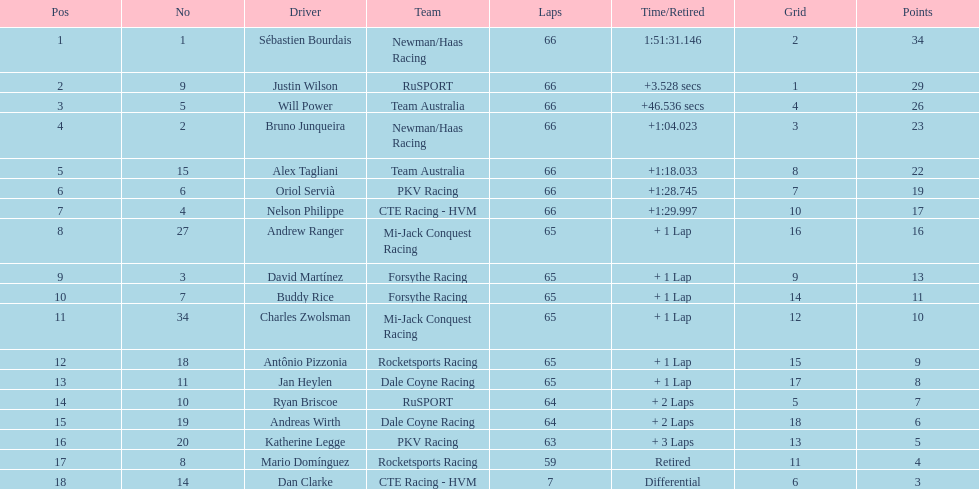In which nation are the highest number of drivers represented? United Kingdom. 